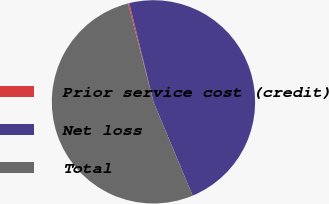<chart> <loc_0><loc_0><loc_500><loc_500><pie_chart><fcel>Prior service cost (credit)<fcel>Net loss<fcel>Total<nl><fcel>0.21%<fcel>47.52%<fcel>52.27%<nl></chart> 